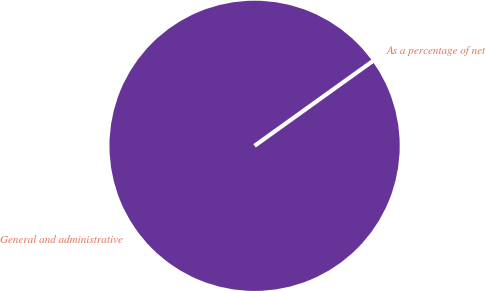Convert chart. <chart><loc_0><loc_0><loc_500><loc_500><pie_chart><fcel>General and administrative<fcel>As a percentage of net<nl><fcel>100.0%<fcel>0.0%<nl></chart> 